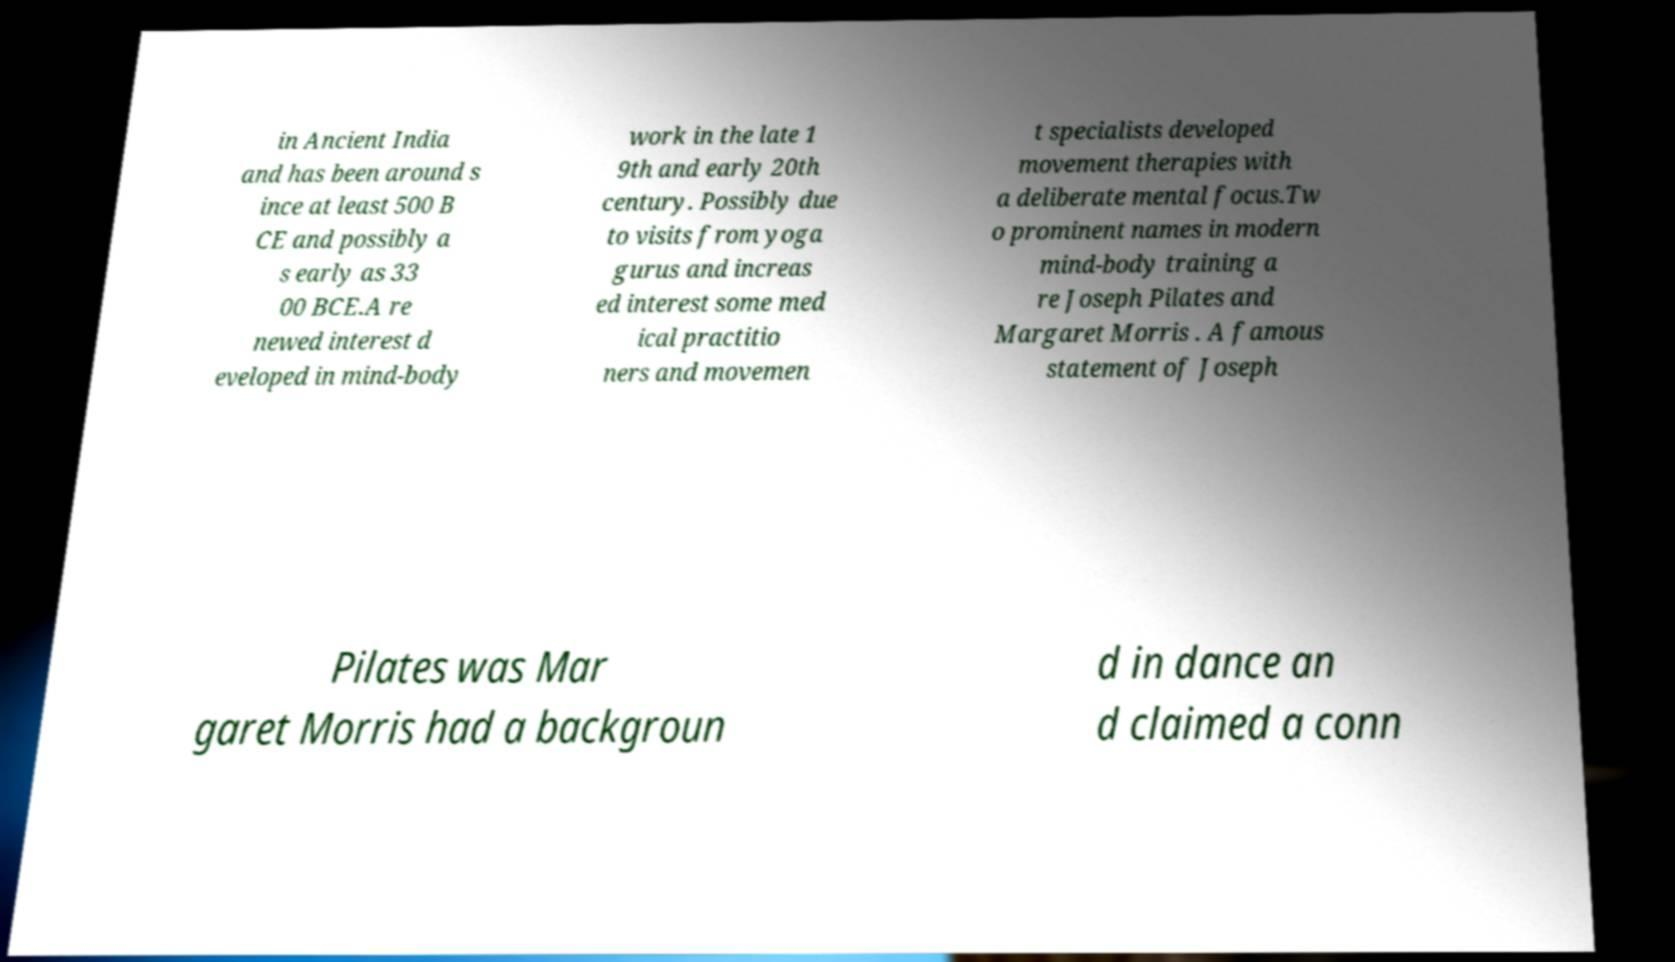Please read and relay the text visible in this image. What does it say? in Ancient India and has been around s ince at least 500 B CE and possibly a s early as 33 00 BCE.A re newed interest d eveloped in mind-body work in the late 1 9th and early 20th century. Possibly due to visits from yoga gurus and increas ed interest some med ical practitio ners and movemen t specialists developed movement therapies with a deliberate mental focus.Tw o prominent names in modern mind-body training a re Joseph Pilates and Margaret Morris . A famous statement of Joseph Pilates was Mar garet Morris had a backgroun d in dance an d claimed a conn 